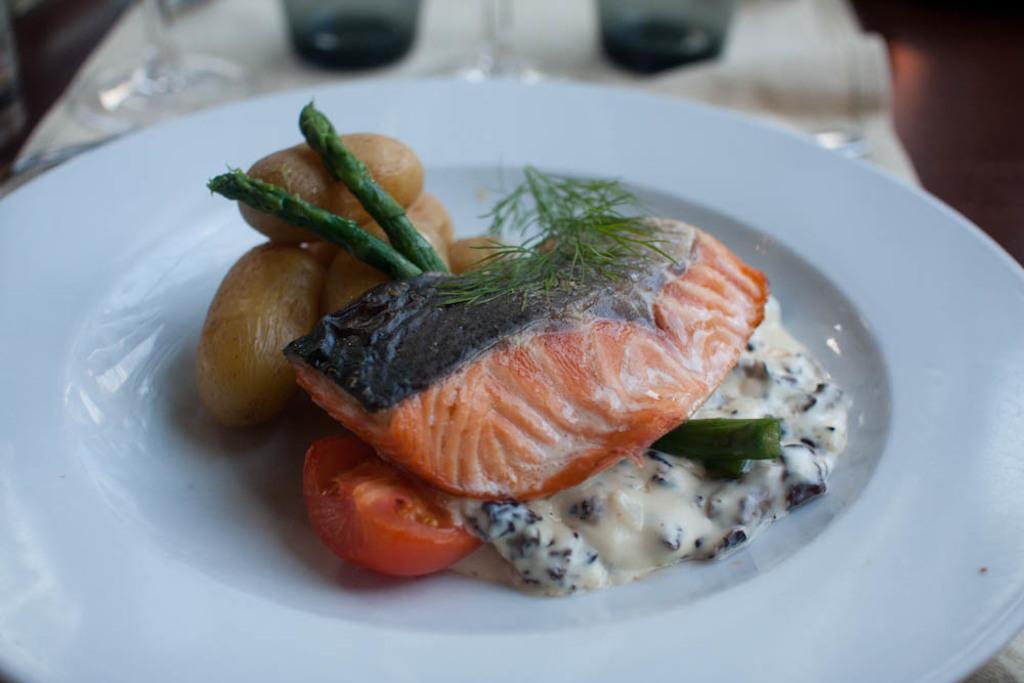Can you describe this image briefly? In this picture we can see food in the plate and in the background we can see few objects. 